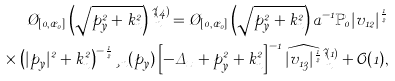Convert formula to latex. <formula><loc_0><loc_0><loc_500><loc_500>\chi _ { [ 0 , \rho _ { 0 } ] } \left ( \sqrt { p _ { y } ^ { 2 } + k _ { n } ^ { 2 } } \right ) \hat { \varphi } ^ { ( 4 ) } _ { n } = \chi _ { [ 0 , \rho _ { 0 } ] } \left ( \sqrt { p _ { y } ^ { 2 } + k _ { n } ^ { 2 } } \right ) a ^ { - 1 } \mathbb { P } _ { 0 } | v _ { 1 2 } | ^ { \frac { 1 } { 2 } } \\ \times \left ( | p _ { y } | ^ { 2 } + k _ { n } ^ { 2 } \right ) ^ { - \frac { 1 } { 2 } } \xi _ { n } ( p _ { y } ) \left [ - \Delta _ { x } + p _ { y } ^ { 2 } + k _ { n } ^ { 2 } \right ] ^ { - 1 } \widehat { | v _ { 1 3 } | ^ { \frac { 1 } { 2 } } } \hat { \varphi } ^ { ( 1 ) } _ { n } + \mathcal { O } ( 1 ) ,</formula> 